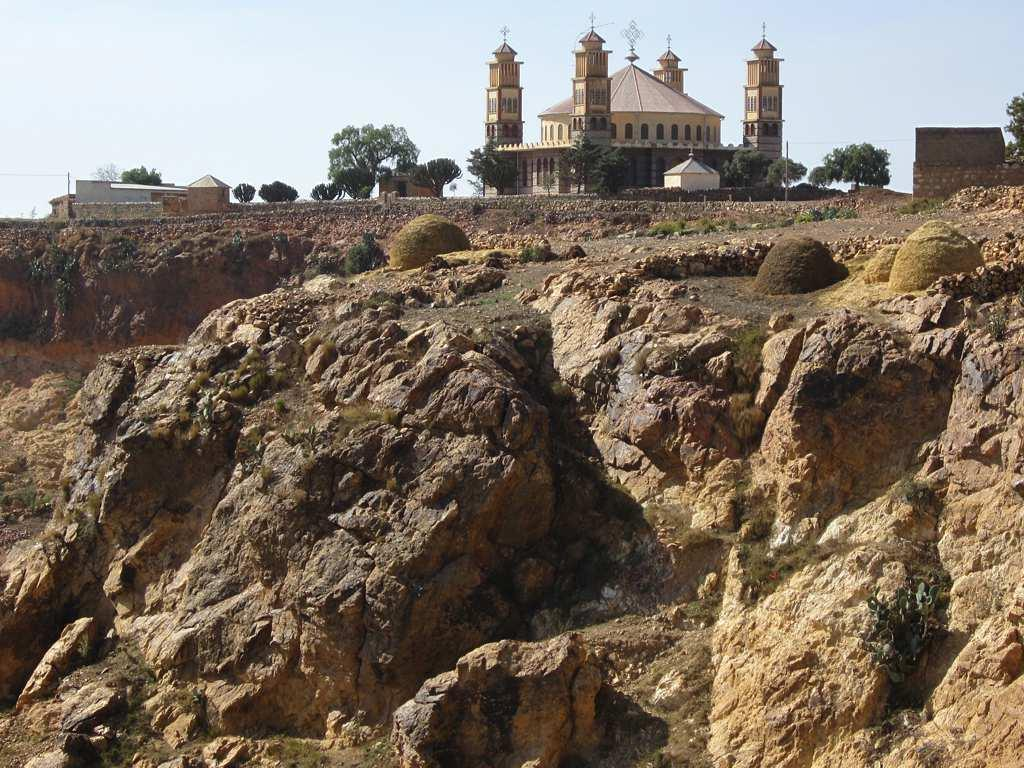What type of structure is present in the image? There is a building in the image. Are there any residential structures in the image? Yes, there are houses in the image. What type of natural elements can be seen in the image? There are trees and rocks visible in the image. How would you describe the weather in the image? The sky is cloudy in the image, suggesting a potentially overcast or rainy day. Can you tell me how many people are skating on the rocks in the image? There is no indication of people skating on the rocks in the image; it only shows a building, houses, trees, rocks, and a cloudy sky. What emotions are the trees expressing in the image? Trees do not express emotions, so this question cannot be answered based on the image. 